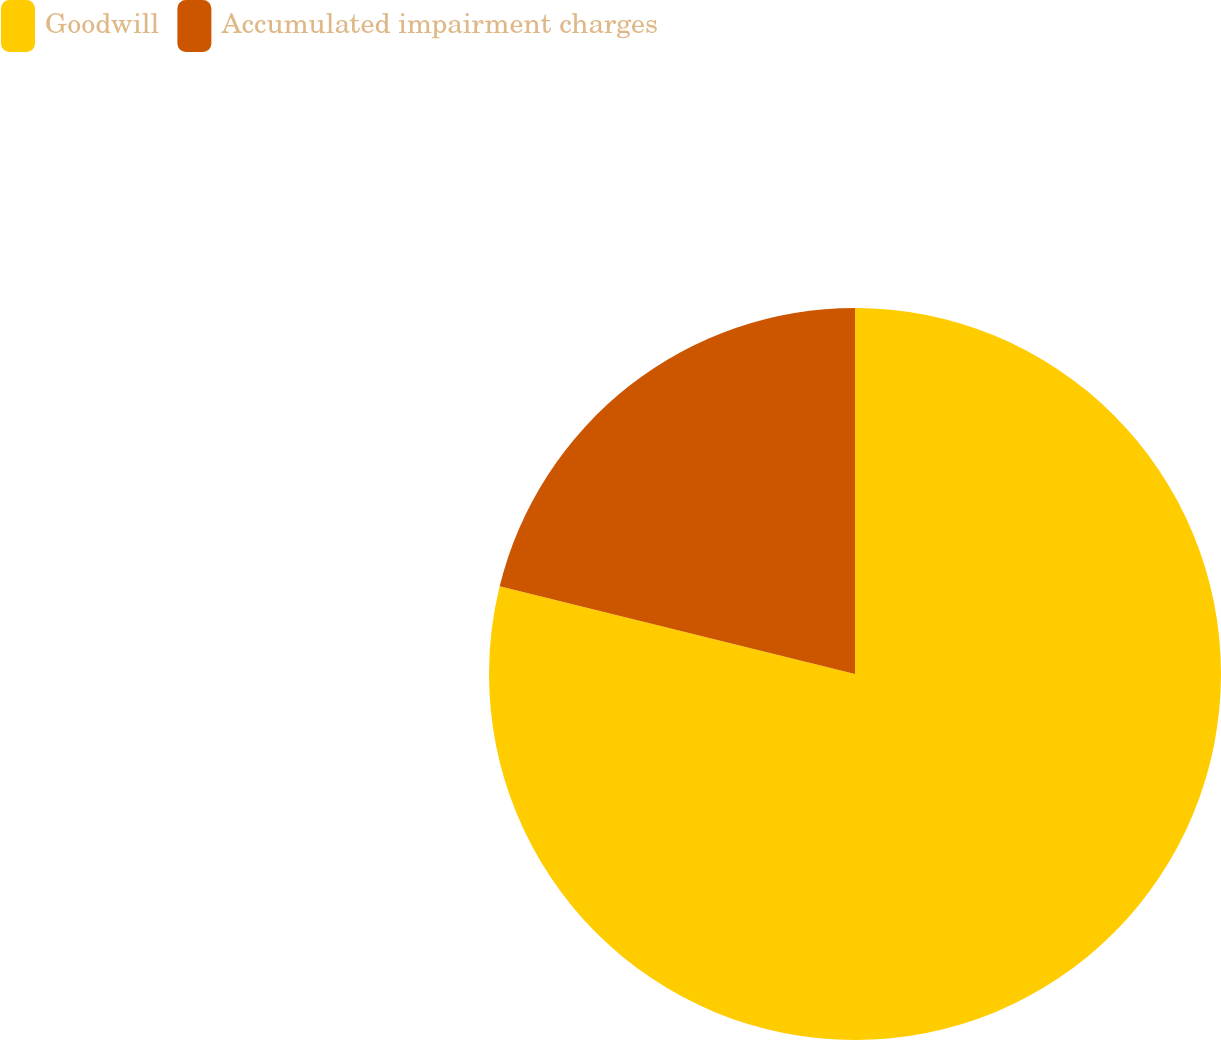Convert chart to OTSL. <chart><loc_0><loc_0><loc_500><loc_500><pie_chart><fcel>Goodwill<fcel>Accumulated impairment charges<nl><fcel>78.85%<fcel>21.15%<nl></chart> 